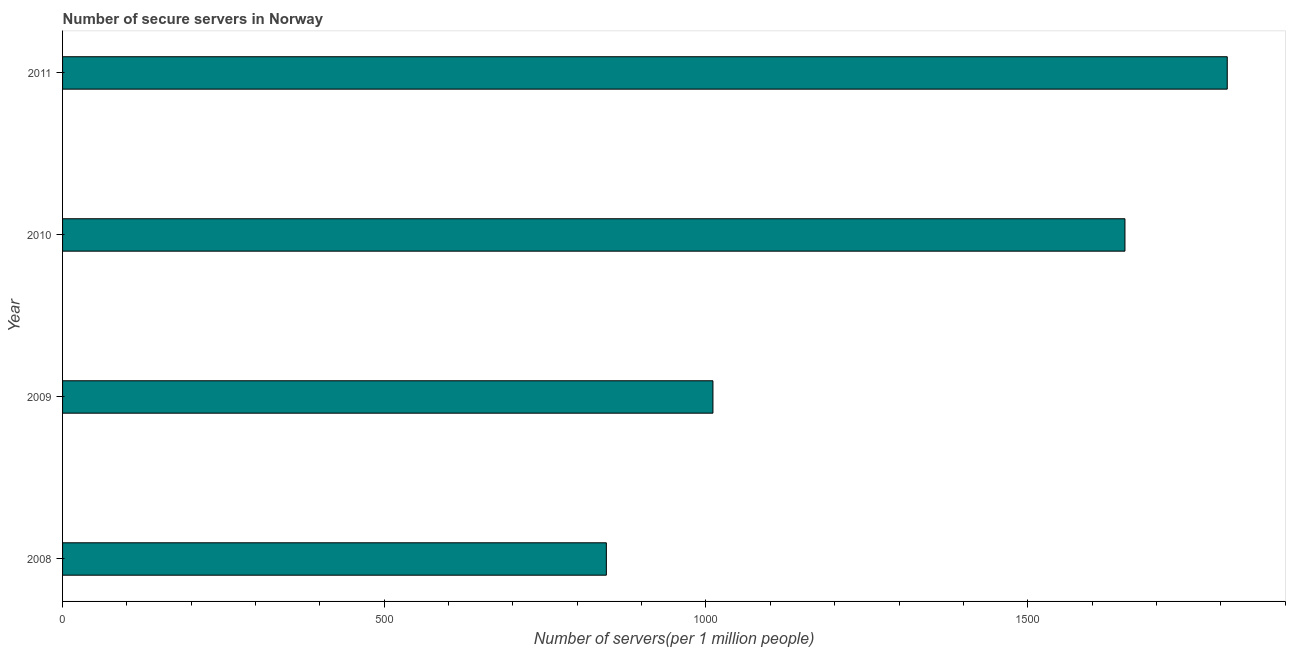Does the graph contain any zero values?
Your answer should be very brief. No. Does the graph contain grids?
Make the answer very short. No. What is the title of the graph?
Your answer should be very brief. Number of secure servers in Norway. What is the label or title of the X-axis?
Offer a terse response. Number of servers(per 1 million people). What is the number of secure internet servers in 2010?
Keep it short and to the point. 1651.17. Across all years, what is the maximum number of secure internet servers?
Give a very brief answer. 1810.18. Across all years, what is the minimum number of secure internet servers?
Your response must be concise. 845.18. In which year was the number of secure internet servers maximum?
Keep it short and to the point. 2011. What is the sum of the number of secure internet servers?
Provide a short and direct response. 5317.36. What is the difference between the number of secure internet servers in 2008 and 2009?
Provide a succinct answer. -165.65. What is the average number of secure internet servers per year?
Provide a short and direct response. 1329.34. What is the median number of secure internet servers?
Give a very brief answer. 1331. In how many years, is the number of secure internet servers greater than 1600 ?
Provide a succinct answer. 2. Do a majority of the years between 2011 and 2010 (inclusive) have number of secure internet servers greater than 1700 ?
Your response must be concise. No. What is the ratio of the number of secure internet servers in 2009 to that in 2011?
Ensure brevity in your answer.  0.56. Is the number of secure internet servers in 2008 less than that in 2009?
Offer a very short reply. Yes. Is the difference between the number of secure internet servers in 2010 and 2011 greater than the difference between any two years?
Your answer should be compact. No. What is the difference between the highest and the second highest number of secure internet servers?
Ensure brevity in your answer.  159.01. What is the difference between the highest and the lowest number of secure internet servers?
Offer a very short reply. 965. In how many years, is the number of secure internet servers greater than the average number of secure internet servers taken over all years?
Provide a succinct answer. 2. How many bars are there?
Offer a very short reply. 4. Are all the bars in the graph horizontal?
Your response must be concise. Yes. How many years are there in the graph?
Keep it short and to the point. 4. What is the difference between two consecutive major ticks on the X-axis?
Provide a succinct answer. 500. What is the Number of servers(per 1 million people) of 2008?
Ensure brevity in your answer.  845.18. What is the Number of servers(per 1 million people) in 2009?
Your response must be concise. 1010.83. What is the Number of servers(per 1 million people) of 2010?
Make the answer very short. 1651.17. What is the Number of servers(per 1 million people) of 2011?
Provide a short and direct response. 1810.18. What is the difference between the Number of servers(per 1 million people) in 2008 and 2009?
Your response must be concise. -165.65. What is the difference between the Number of servers(per 1 million people) in 2008 and 2010?
Your answer should be very brief. -805.99. What is the difference between the Number of servers(per 1 million people) in 2008 and 2011?
Make the answer very short. -965. What is the difference between the Number of servers(per 1 million people) in 2009 and 2010?
Your answer should be very brief. -640.35. What is the difference between the Number of servers(per 1 million people) in 2009 and 2011?
Provide a short and direct response. -799.36. What is the difference between the Number of servers(per 1 million people) in 2010 and 2011?
Offer a terse response. -159.01. What is the ratio of the Number of servers(per 1 million people) in 2008 to that in 2009?
Provide a short and direct response. 0.84. What is the ratio of the Number of servers(per 1 million people) in 2008 to that in 2010?
Your answer should be compact. 0.51. What is the ratio of the Number of servers(per 1 million people) in 2008 to that in 2011?
Offer a terse response. 0.47. What is the ratio of the Number of servers(per 1 million people) in 2009 to that in 2010?
Your answer should be very brief. 0.61. What is the ratio of the Number of servers(per 1 million people) in 2009 to that in 2011?
Ensure brevity in your answer.  0.56. What is the ratio of the Number of servers(per 1 million people) in 2010 to that in 2011?
Provide a succinct answer. 0.91. 